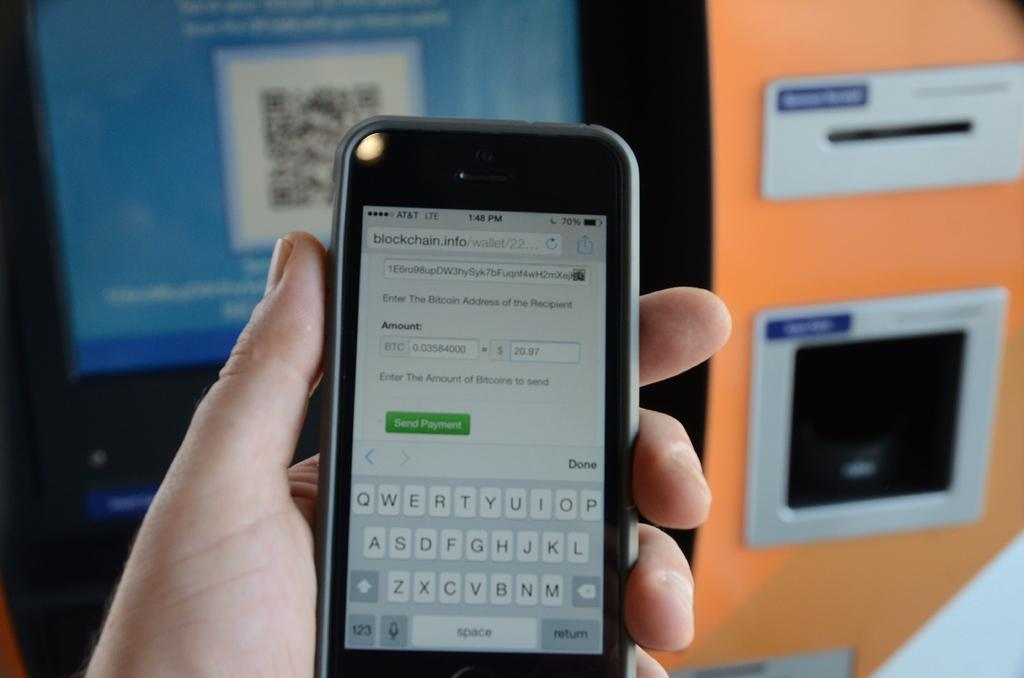<image>
Give a short and clear explanation of the subsequent image. A phone with the website blockchain.info pulled up on the screen is being held. 